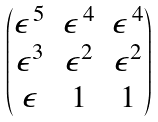<formula> <loc_0><loc_0><loc_500><loc_500>\begin{pmatrix} \epsilon ^ { \, 5 } & \epsilon ^ { \, 4 } & \epsilon ^ { \, 4 } \\ \epsilon ^ { 3 } & \epsilon ^ { 2 } & \epsilon ^ { 2 } \\ \epsilon & 1 & 1 \end{pmatrix}</formula> 